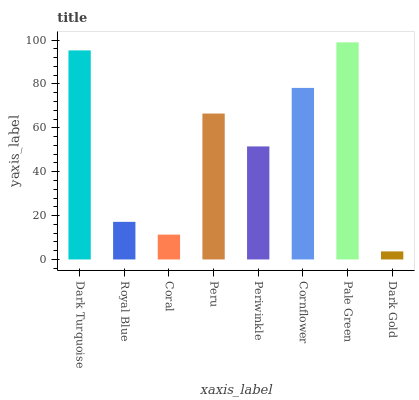Is Royal Blue the minimum?
Answer yes or no. No. Is Royal Blue the maximum?
Answer yes or no. No. Is Dark Turquoise greater than Royal Blue?
Answer yes or no. Yes. Is Royal Blue less than Dark Turquoise?
Answer yes or no. Yes. Is Royal Blue greater than Dark Turquoise?
Answer yes or no. No. Is Dark Turquoise less than Royal Blue?
Answer yes or no. No. Is Peru the high median?
Answer yes or no. Yes. Is Periwinkle the low median?
Answer yes or no. Yes. Is Dark Turquoise the high median?
Answer yes or no. No. Is Dark Turquoise the low median?
Answer yes or no. No. 